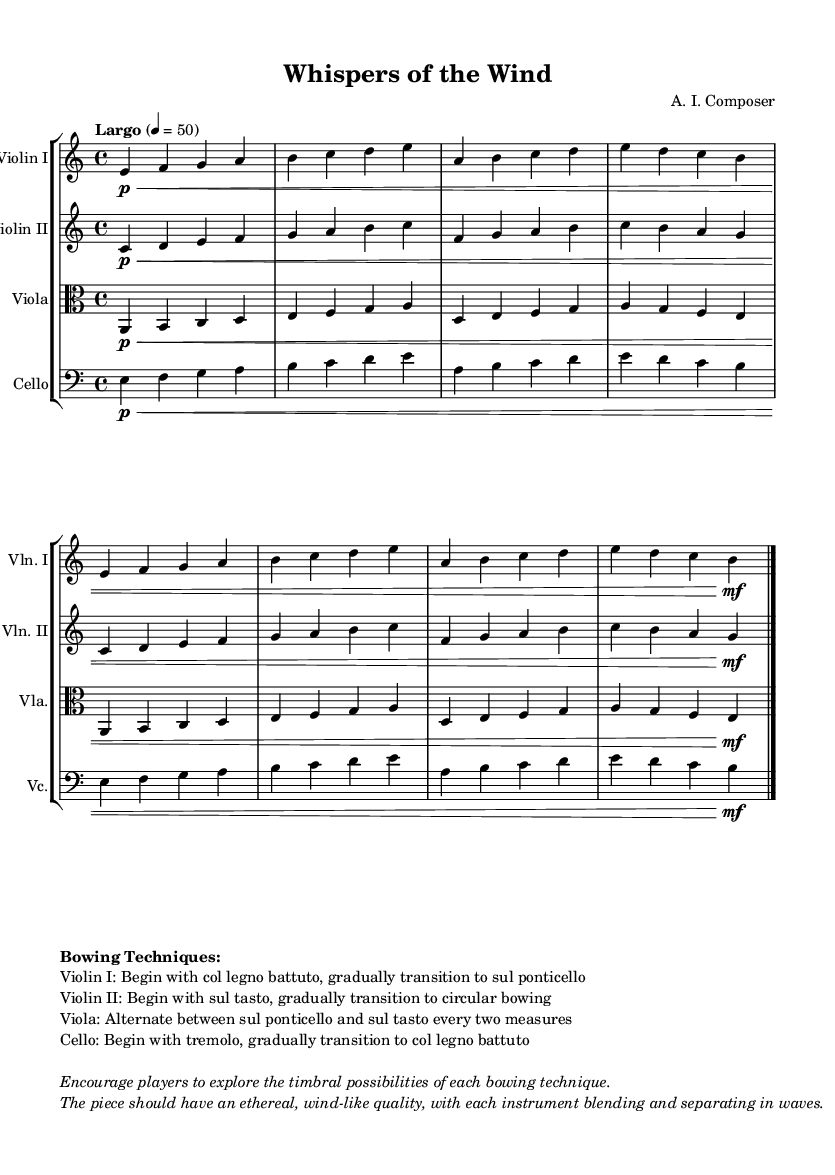What is the key signature of this music? The key signature shows two flats, indicating it is in A minor.
Answer: A minor What is the time signature of the piece? The time signature is indicated as 4/4, which means there are four beats in a measure.
Answer: 4/4 What is the tempo marking for the piece? The tempo is marked "Largo" with a metronome marking of 50, indicating a slow pace.
Answer: Largo, 50 Which bowing technique is suggested for Violin I at the beginning? The sheet music indicates that Violin I should start with col legno battuto, which involves striking the strings with the wooden part of the bow.
Answer: col legno battuto What bowing technique is used for Viola throughout the piece? The instruction says to alternate between sul ponticello and sul tasto every two measures, which creates a varied sound color.
Answer: sul ponticello and sul tasto What emotional quality is emphasized in the piece? The instructions in the markup suggest an ethereal, wind-like quality, emphasizing the blending and separation of sounds among the instruments.
Answer: ethereal, wind-like What is the primary function of the tremolo in the Cello part? The tremolo technique introduces a sustained, wavering sound that adds a dynamic texture before the transition to col legno battuto.
Answer: sustained, wavering sound 